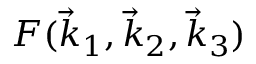<formula> <loc_0><loc_0><loc_500><loc_500>F ( \vec { k } _ { 1 } , \vec { k } _ { 2 } , \vec { k } _ { 3 } )</formula> 